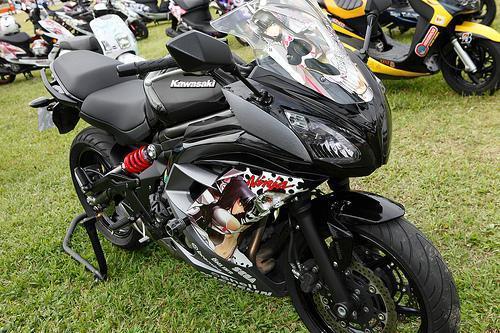How many tires does the bike have?
Give a very brief answer. 2. How many wheels on a motorcycle?
Give a very brief answer. 2. 